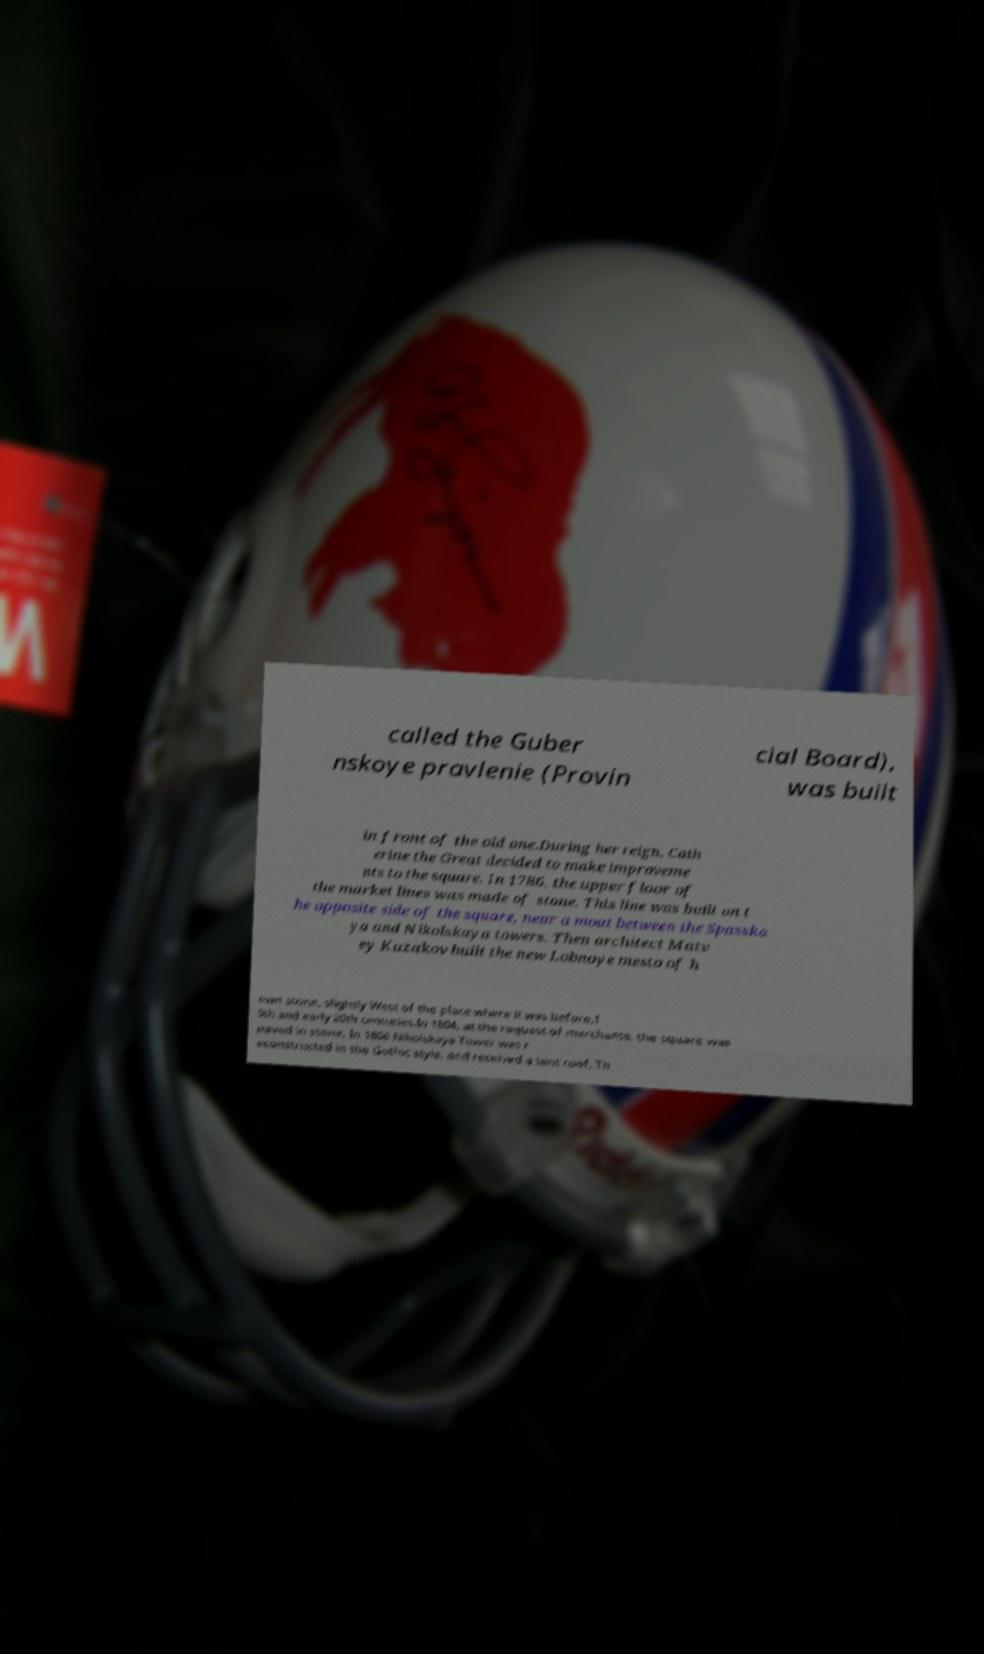Can you read and provide the text displayed in the image?This photo seems to have some interesting text. Can you extract and type it out for me? called the Guber nskoye pravlenie (Provin cial Board), was built in front of the old one.During her reign, Cath erine the Great decided to make improveme nts to the square. In 1786, the upper floor of the market lines was made of stone. This line was built on t he opposite side of the square, near a moat between the Spasska ya and Nikolskaya towers. Then architect Matv ey Kazakov built the new Lobnoye mesto of h ewn stone, slightly West of the place where it was before.1 9th and early 20th centuries.In 1804, at the request of merchants, the square was paved in stone. In 1806 Nikolskaya Tower was r econstructed in the Gothic style, and received a tent roof. Th 